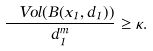<formula> <loc_0><loc_0><loc_500><loc_500>\frac { \ V o l ( B ( x _ { 1 } , d _ { 1 } ) ) } { d _ { 1 } ^ { m } } \geq \kappa .</formula> 